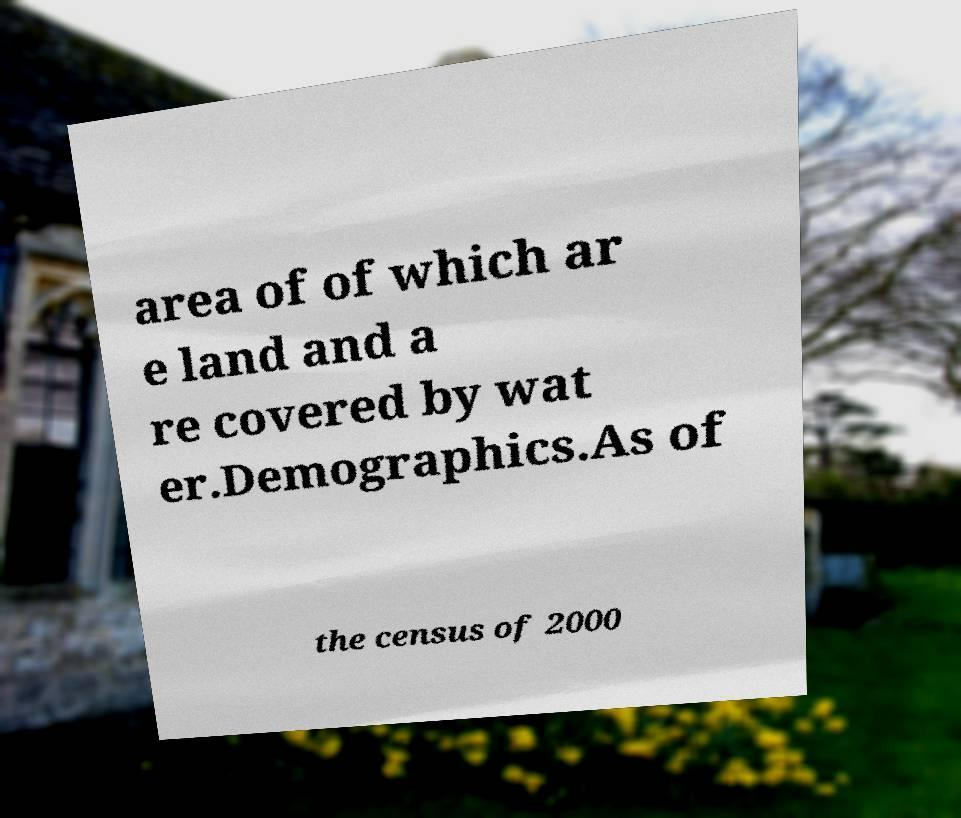For documentation purposes, I need the text within this image transcribed. Could you provide that? area of of which ar e land and a re covered by wat er.Demographics.As of the census of 2000 